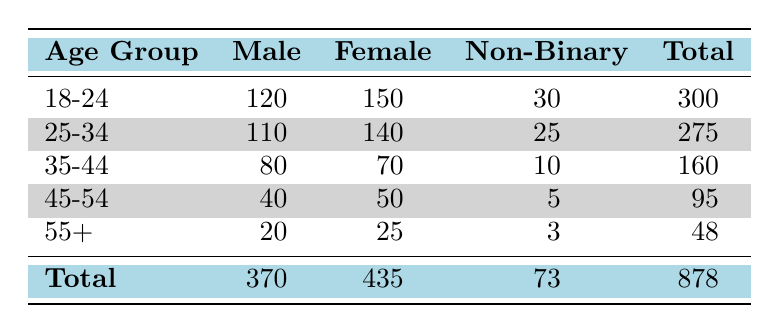What is the total number of males with access to online training resources? To find the total number of males, we sum the values in the Male column: 120 + 110 + 80 + 40 + 20 = 370.
Answer: 370 What is the number of females in the 25-34 age group? The table shows the value in the Female column for the age group 25-34 is 140.
Answer: 140 Is there more access to online training resources for non-binary individuals than for older males (age 45-54 and 55+)? The total non-binary access is 30 + 25 + 10 + 5 + 3 = 73. The total for older males is 40 + 20 = 60. Since 73 is greater than 60, the statement is true.
Answer: Yes What is the average number of females across all age groups? To calculate the average, we first sum the number of females: 150 + 140 + 70 + 50 + 25 = 435. There are 5 age groups, so the average is 435/5 = 87.
Answer: 87 What percentage of the total population does the 35-44 age group represent? The total population is 878. The number in the 35-44 age group is 160. To find the percentage, we calculate (160/878) * 100, which is approximately 18.2%.
Answer: 18.2% What is the difference in access between the highest and the lowest age group for females? The highest value in the Female column is 150 (from the 18-24 age group), and the lowest is 25 (from the 55+ group). The difference is 150 - 25 = 125.
Answer: 125 Are there more males in the 18-24 age group than females in the 45-54 age group? From the table, males in 18-24 have 120 access and females in 45-54 have 50 access. Since 120 is greater than 50, the statement is true.
Answer: Yes How many more males than non-binary individuals there are in the 25-34 age group? In the 25-34 age group, there are 110 males and 25 non-binary individuals. The difference is 110 - 25 = 85.
Answer: 85 What is the total access to online training resources for the 45-54 age group? To calculate the total for the 45-54 age group, we sum the values in that row: 40 (Male) + 50 (Female) + 5 (Non-Binary) = 95.
Answer: 95 